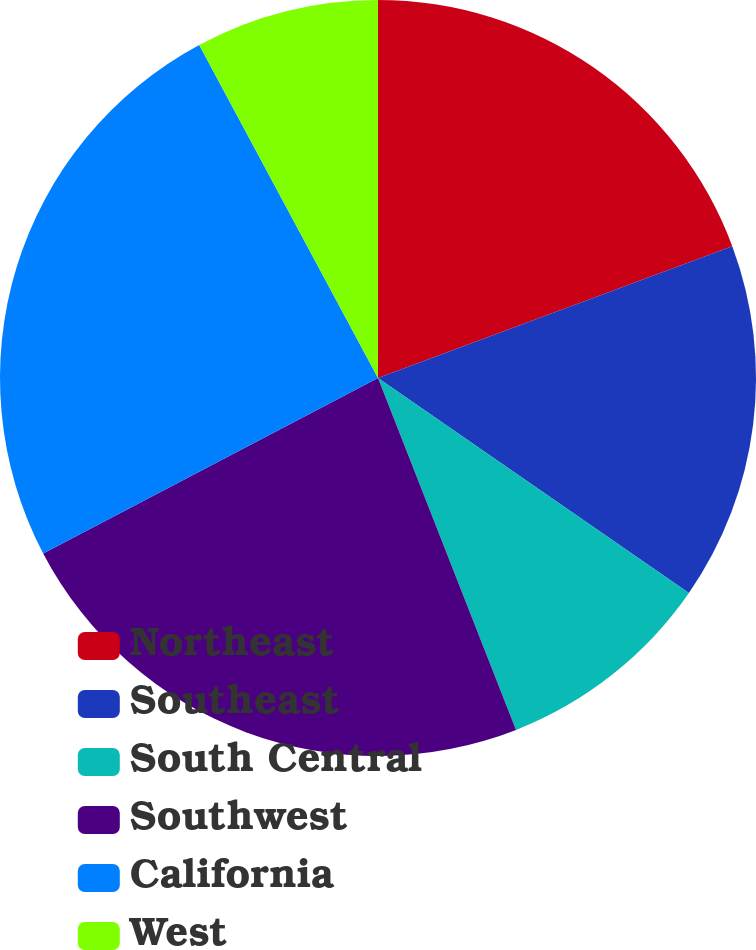<chart> <loc_0><loc_0><loc_500><loc_500><pie_chart><fcel>Northeast<fcel>Southeast<fcel>South Central<fcel>Southwest<fcel>California<fcel>West<nl><fcel>19.33%<fcel>15.3%<fcel>9.42%<fcel>23.27%<fcel>24.84%<fcel>7.84%<nl></chart> 